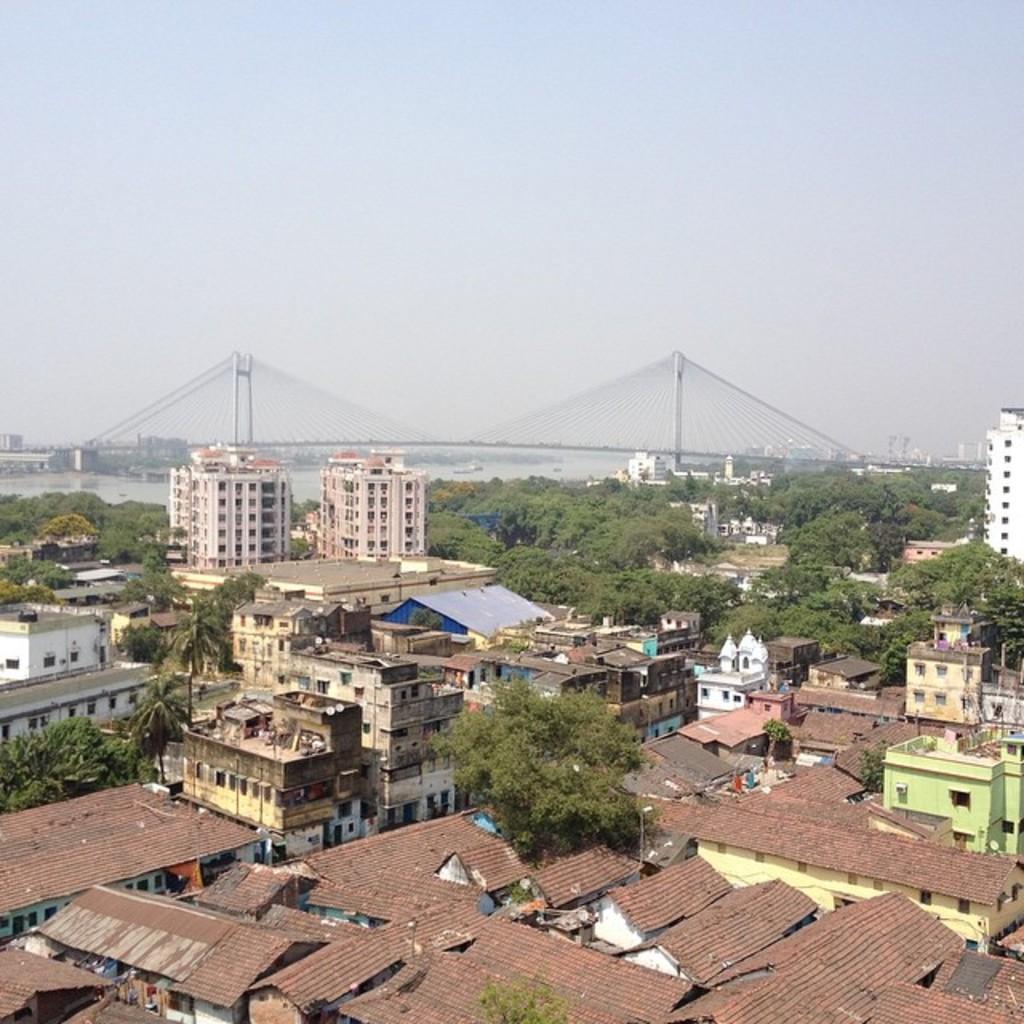Please provide a concise description of this image. In this image there is a view of the city, there are buildingś, there are houseś, there are treeś, there is sky, there is a bridge, there is a river. 